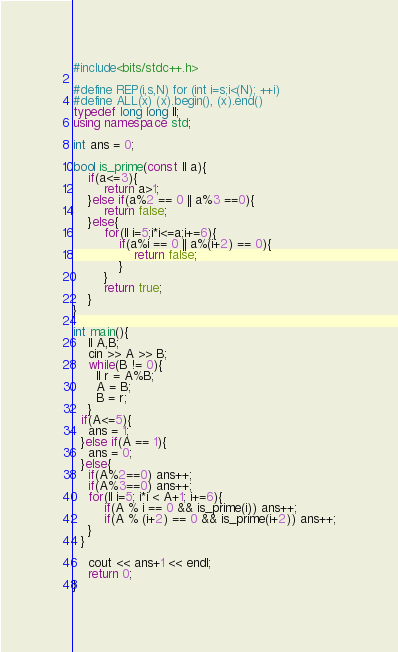<code> <loc_0><loc_0><loc_500><loc_500><_C++_>#include<bits/stdc++.h>
 
#define REP(i,s,N) for (int i=s;i<(N); ++i)
#define ALL(x) (x).begin(), (x).end()
typedef long long ll;
using namespace std;

int ans = 0;

bool is_prime(const ll a){
	if(a<=3){
		return a>1;
	}else if(a%2 == 0 || a%3 ==0){
		return false;
	}else{
		for(ll i=5;i*i<=a;i+=6){
			if(a%i == 0 || a%(i+2) == 0){
				return false;
			}
		}
		return true;
	}
}

int main(){
	ll A,B;
	cin >> A >> B;
	while(B != 0){
      ll r = A%B;
      A = B;
      B = r;
    }
  if(A<=5){
    ans = 1;
  }else if(A == 1){
    ans = 0;
  }else{
    if(A%2==0) ans++;
    if(A%3==0) ans++;
    for(ll i=5; i*i < A+1; i+=6){
        if(A % i == 0 && is_prime(i)) ans++;
        if(A % (i+2) == 0 && is_prime(i+2)) ans++;
    }
  }
	
    cout << ans+1 << endl;
	return 0;
}</code> 